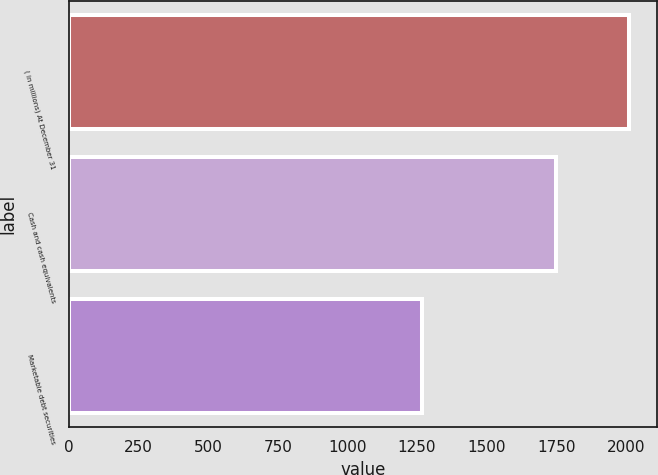Convert chart to OTSL. <chart><loc_0><loc_0><loc_500><loc_500><bar_chart><fcel>( in millions) At December 31<fcel>Cash and cash equivalents<fcel>Marketable debt securities<nl><fcel>2013<fcel>1750.1<fcel>1267.5<nl></chart> 